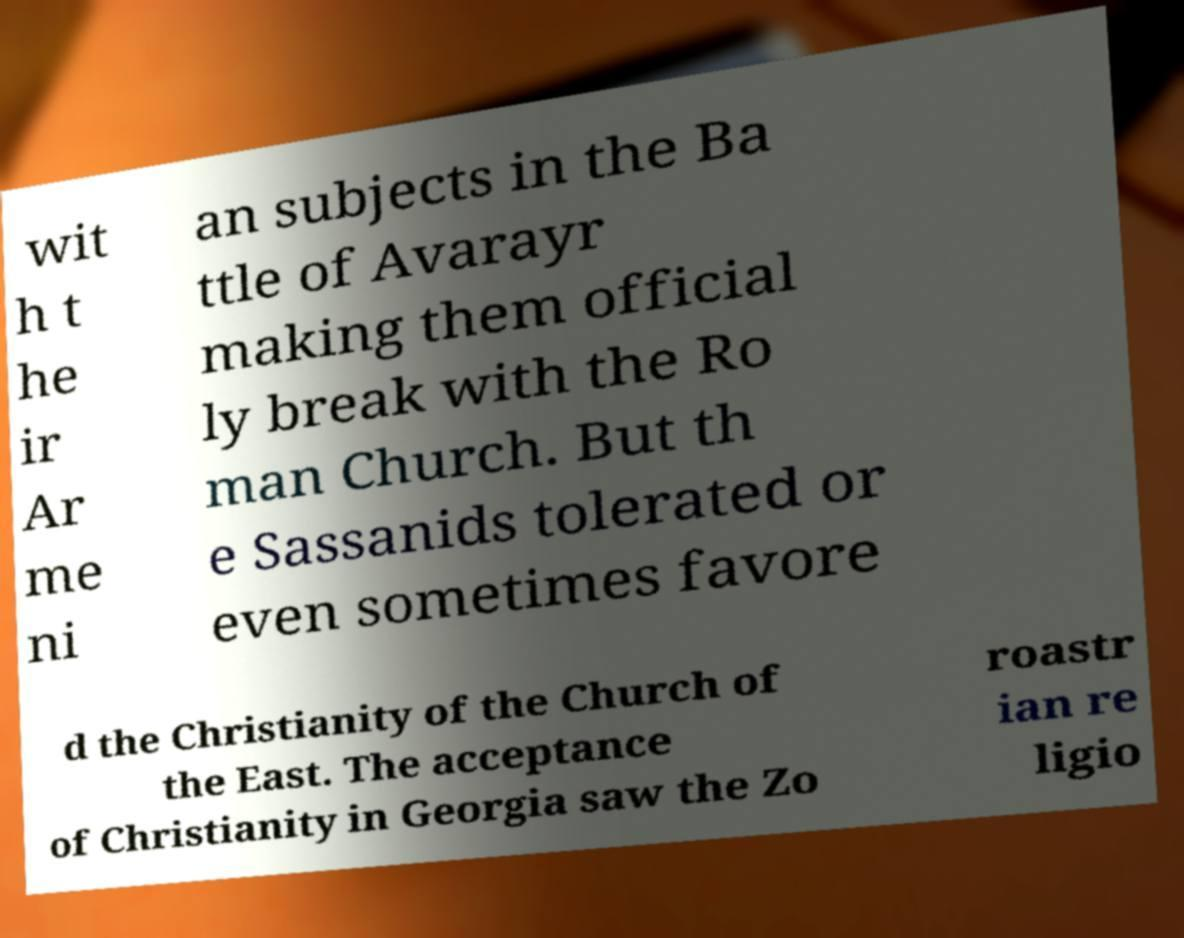For documentation purposes, I need the text within this image transcribed. Could you provide that? wit h t he ir Ar me ni an subjects in the Ba ttle of Avarayr making them official ly break with the Ro man Church. But th e Sassanids tolerated or even sometimes favore d the Christianity of the Church of the East. The acceptance of Christianity in Georgia saw the Zo roastr ian re ligio 